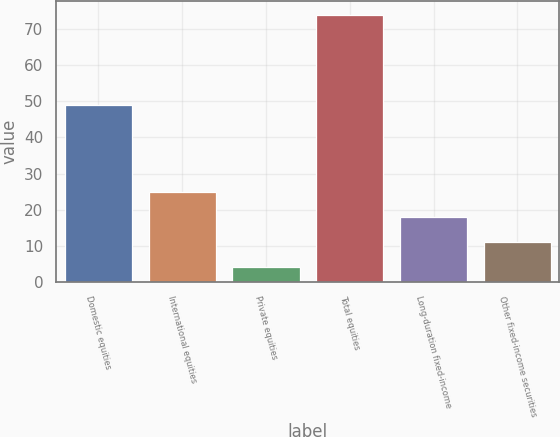Convert chart. <chart><loc_0><loc_0><loc_500><loc_500><bar_chart><fcel>Domestic equities<fcel>International equities<fcel>Private equities<fcel>Total equities<fcel>Long-duration fixed-income<fcel>Other fixed-income securities<nl><fcel>49<fcel>25<fcel>4<fcel>74<fcel>18<fcel>11<nl></chart> 